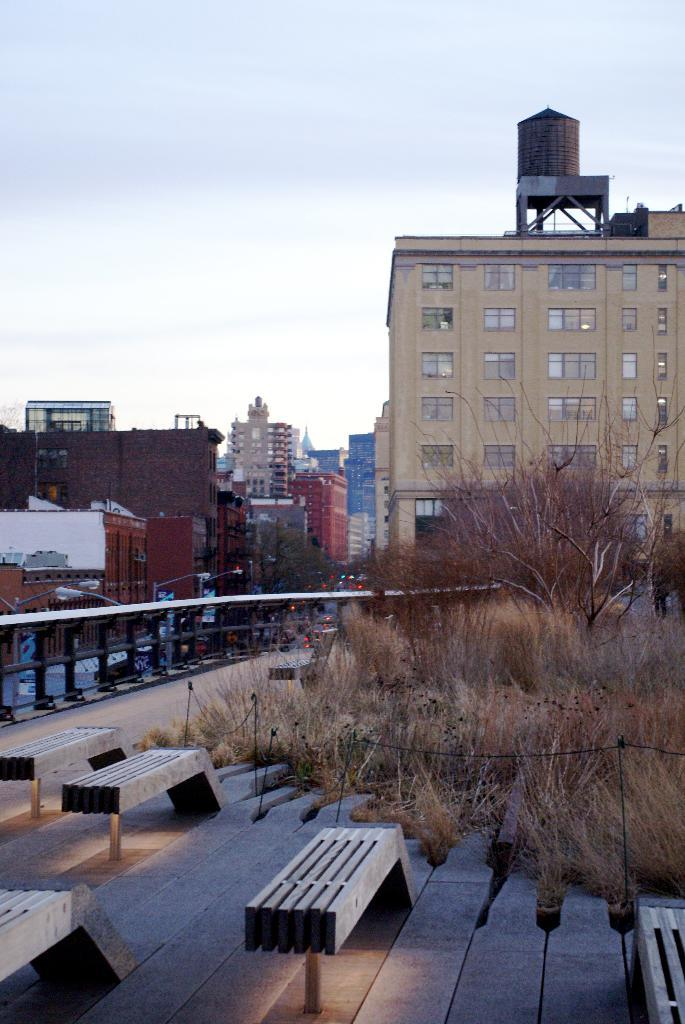What can be seen in the foreground of the image? In the foreground of the image, there are shelters, poles, and trees. What is visible in the background of the image? In the background of the image, there are buildings, vehicles moving on the road, a flyover, and the sky. What is the condition of the sky in the image? The sky is visible in the background of the image, and there are clouds present. What type of soup is being served in the shelters in the image? There is no soup present in the image; the shelters are empty structures. What type of ground is visible beneath the flyover in the image? The ground is not visible beneath the flyover in the image; only the flyover and the vehicles moving on the road are visible. 